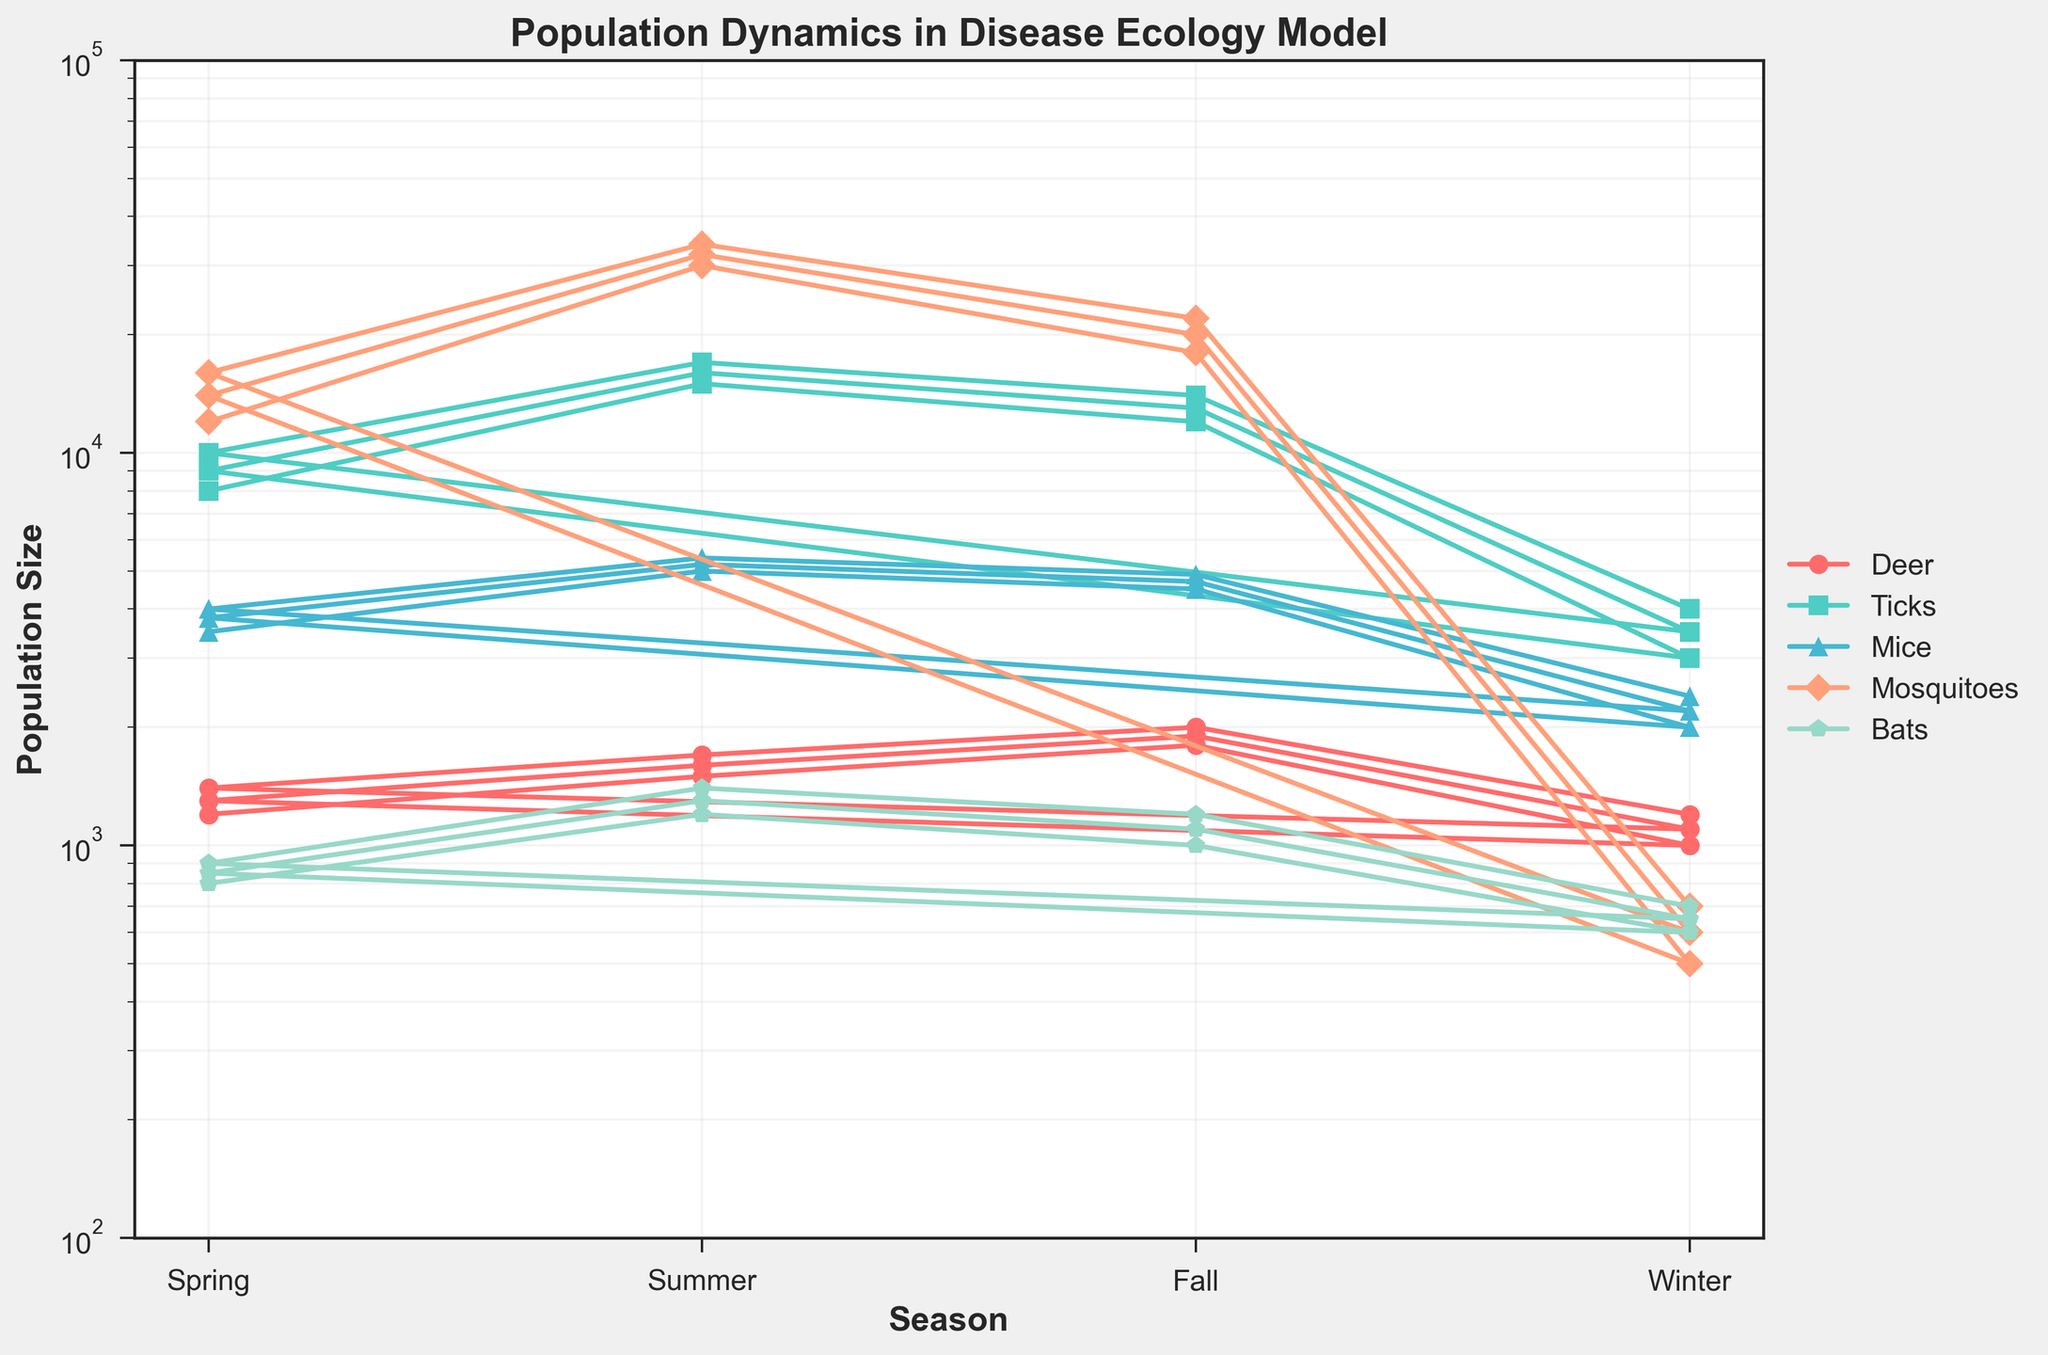Which species has the highest population size during the summer season? In the figure, we observe the population sizes of all species during the summer season. The highest data point here represents mosquitoes, with a population size reaching 34,000.
Answer: Mosquitoes What is the relative difference in population sizes between ticks and deer in the summer? During the summer, the deer population is 1,500, while the tick population is 15,000. To find the relative difference, we calculate (15,000 - 1,500) / 1,500 = 13,500 / 1,500 = 9
Answer: 9 times larger What is the total population of bats across all seasons represented in the data? Sum the bat populations: 800 + 1200 + 1000 + 600 + 850 + 1300 + 1100 + 650 + 900 + 1400 + 1200 + 700 = 11700
Answer: 11700 Which season shows the lowest population size for mosquitoes, and what is that size? Referring to the figure, the lowest population size for mosquitoes appears in the winter seasons with the value being 500 and 600.
Answer: Winter, 500 Compare the population trends of deer and mice. How does the population of these two species change when transitioning from spring to fall? From spring to fall, the deer population increases from 1200 to 1800 while the mice population increases from 3500 to 4500. This trend is consistent across the two cycles in the data.
Answer: Both increase In which season do ticks have the highest population size, and what is the population at that time? From the plot, we see that the highest population size for ticks is in the summer with the value peaking at 17,000.
Answer: Summer, 17,000 Calculate the average population size of mice during the winter season. The number of mice in the winters are 2000, 2200, and 2400. Average of these values is (2000 + 2200 + 2400) / 3 = 6600 / 3 = 2200.
Answer: 2200 How does the bat population during summer compare to the bat population during winter? In summer, the bat population is 1200 in the first cycle and 1300 and 1400 in the subsequent cycles while in winter it is consistently lower at 600, 650, 700. Hence, bats have a higher population during the summer compared to winter in all cycles.
Answer: Higher in summer Which species demonstrates the most consistent seasonal fluctuation in population size across the entire dataset? Observing the population trends in the chart, ticks show a very consistent pattern of increase and decrease across seasonal transitions in all the cycles, peaking in summer and dropping in winter.
Answer: Ticks 